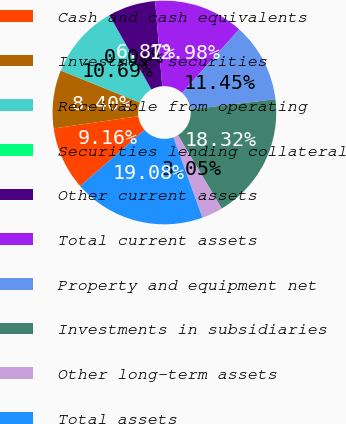<chart> <loc_0><loc_0><loc_500><loc_500><pie_chart><fcel>Cash and cash equivalents<fcel>Investment securities<fcel>Receivable from operating<fcel>Securities lending collateral<fcel>Other current assets<fcel>Total current assets<fcel>Property and equipment net<fcel>Investments in subsidiaries<fcel>Other long-term assets<fcel>Total assets<nl><fcel>9.16%<fcel>8.4%<fcel>10.69%<fcel>0.0%<fcel>6.87%<fcel>12.98%<fcel>11.45%<fcel>18.32%<fcel>3.05%<fcel>19.08%<nl></chart> 